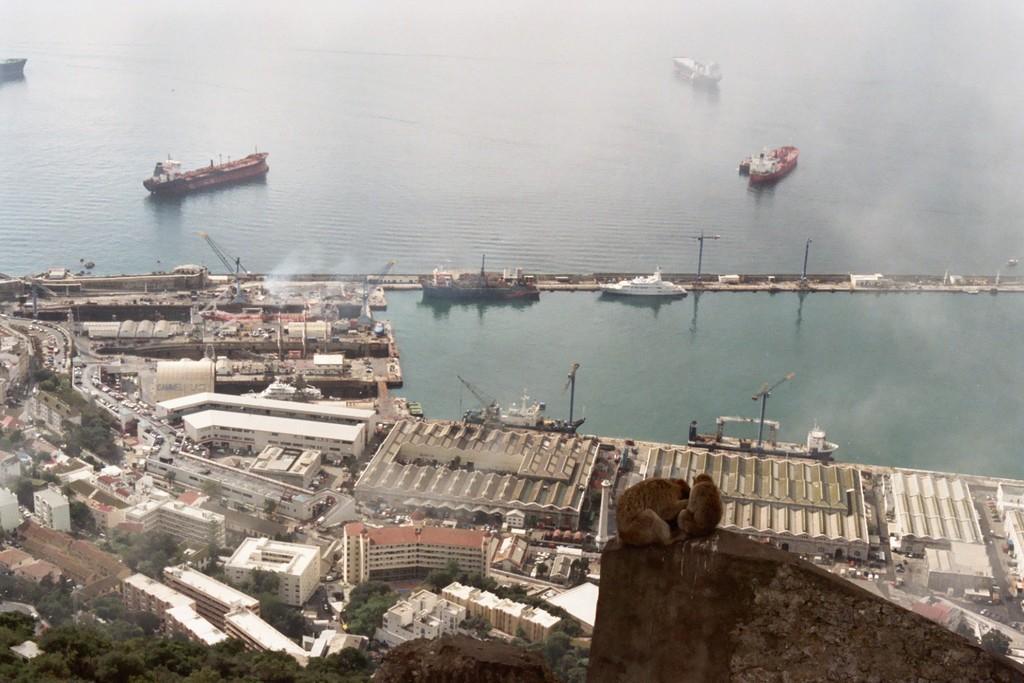Can you describe this image briefly? In this image we can see a group of ships in the water. We can also see a group of buildings, poles, a group of vehicles on the road, a crane, trees and two monkeys on the surface. 